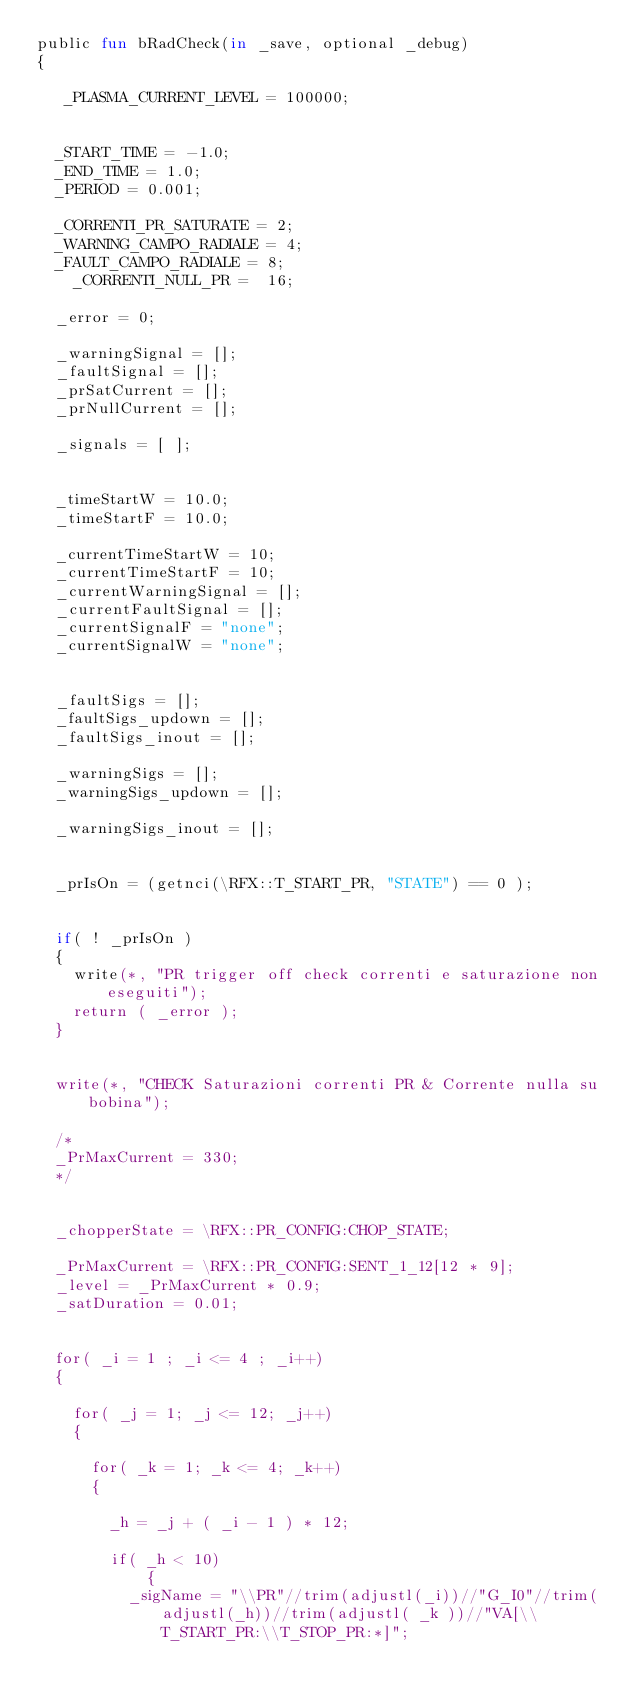<code> <loc_0><loc_0><loc_500><loc_500><_SML_>public fun bRadCheck(in _save, optional _debug)
{

	 _PLASMA_CURRENT_LEVEL = 100000;


	_START_TIME = -1.0;
	_END_TIME = 1.0;
	_PERIOD = 0.001;
	
	_CORRENTI_PR_SATURATE = 2;
	_WARNING_CAMPO_RADIALE = 4;
	_FAULT_CAMPO_RADIALE = 8;
    _CORRENTI_NULL_PR =  16;

	_error = 0;
	
	_warningSignal = [];
	_faultSignal = [];
	_prSatCurrent = [];
	_prNullCurrent = [];
	
	_signals = [ ];


	_timeStartW = 10.0;
	_timeStartF = 10.0;

	_currentTimeStartW = 10;
	_currentTimeStartF = 10;
	_currentWarningSignal = [];	
	_currentFaultSignal = [];
	_currentSignalF = "none";
	_currentSignalW = "none";
	
	
	_faultSigs = [];
	_faultSigs_updown = [];
	_faultSigs_inout = [];

	_warningSigs = [];
	_warningSigs_updown = [];

	_warningSigs_inout = [];


	_prIsOn = (getnci(\RFX::T_START_PR, "STATE") == 0 );


	if( ! _prIsOn ) 
	{
		write(*, "PR trigger off check correnti e saturazione non eseguiti");
		return ( _error );	
	}


	write(*, "CHECK Saturazioni correnti PR & Corrente nulla su bobina");
	
	/*
	_PrMaxCurrent = 330;
	*/


	_chopperState = \RFX::PR_CONFIG:CHOP_STATE;

	_PrMaxCurrent = \RFX::PR_CONFIG:SENT_1_12[12 * 9];
	_level = _PrMaxCurrent * 0.9;
	_satDuration = 0.01;


	for( _i = 1 ; _i <= 4 ; _i++)
	{		

		for( _j = 1; _j <= 12; _j++)
		{
		
			for( _k = 1; _k <= 4; _k++)
			{
			
				_h = _j + ( _i - 1 ) * 12;
	
				if( _h < 10)
            {
					_sigName = "\\PR"//trim(adjustl(_i))//"G_I0"//trim(adjustl(_h))//trim(adjustl( _k ))//"VA[\\T_START_PR:\\T_STOP_PR:*]";</code> 